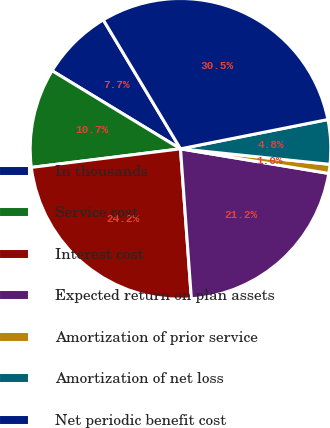<chart> <loc_0><loc_0><loc_500><loc_500><pie_chart><fcel>In thousands<fcel>Service cost<fcel>Interest cost<fcel>Expected return on plan assets<fcel>Amortization of prior service<fcel>Amortization of net loss<fcel>Net periodic benefit cost<nl><fcel>7.72%<fcel>10.67%<fcel>24.18%<fcel>21.23%<fcel>0.97%<fcel>4.77%<fcel>30.46%<nl></chart> 